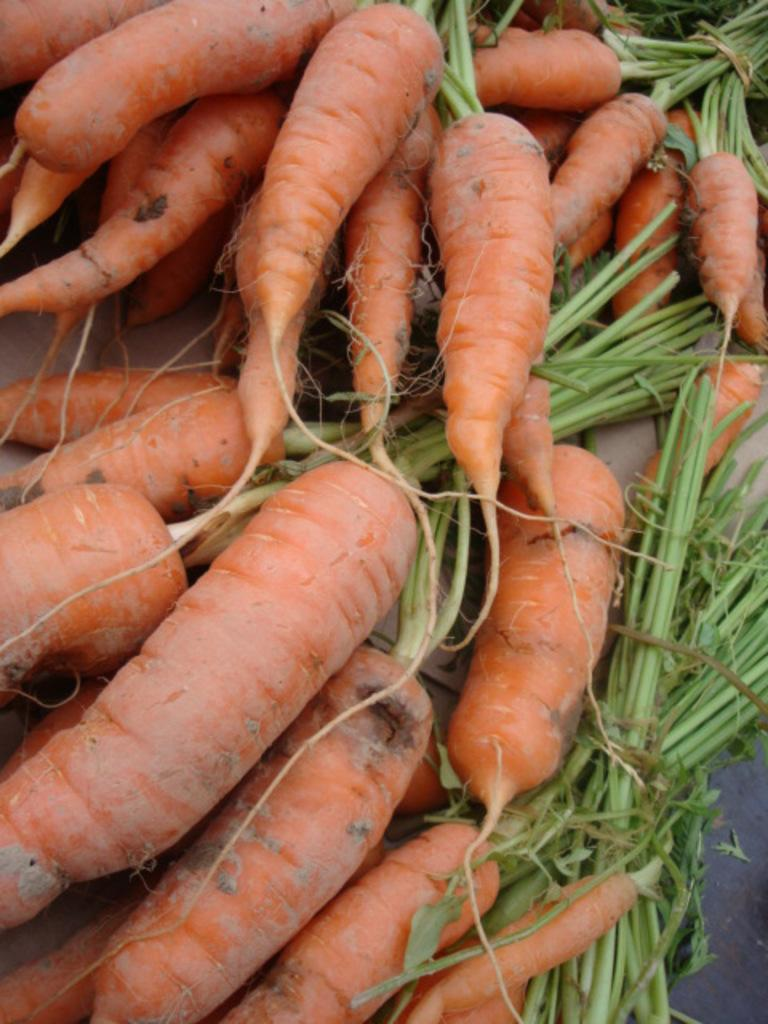What type of vegetable can be seen in the image? There are carrots in the image. What is the color of the carrots? The carrots are orange in color. What else is present in the image besides the carrots? There are leaves in the image. What is the color of the leaves? The leaves are green in color. Where are the carrots and leaves located in the image? The carrots and leaves are on a surface. What scientific discovery is being made in the image? There is no scientific discovery being made in the image; it simply shows carrots and leaves on a surface. 